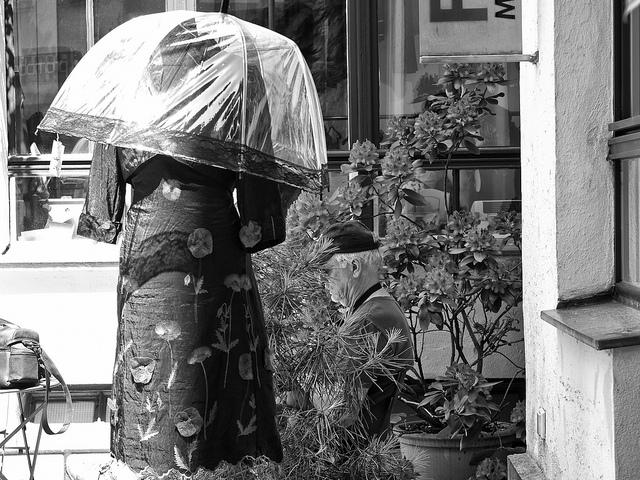What is the woman holding?
Short answer required. Umbrella. How many people are shown?
Write a very short answer. 2. What is the man doing?
Answer briefly. Sitting. 